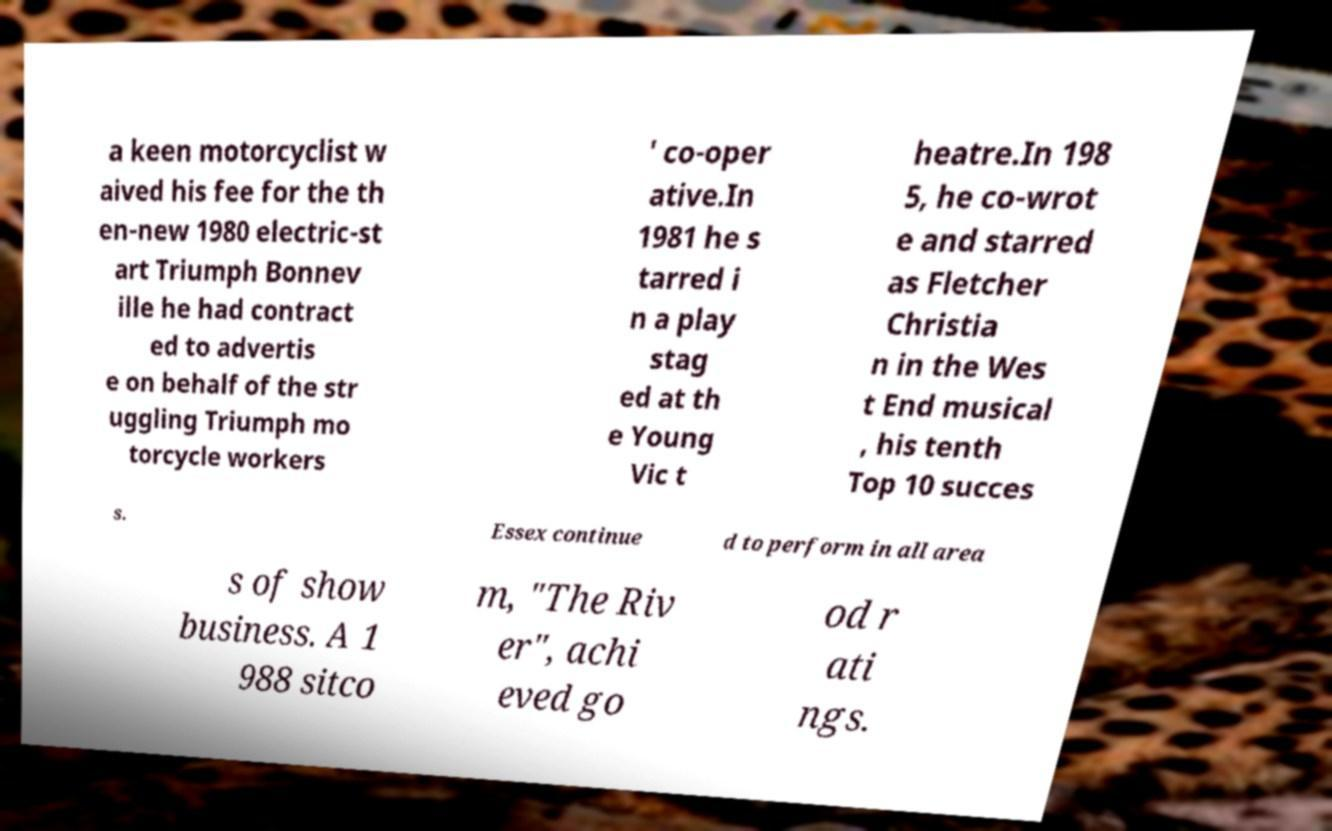Please read and relay the text visible in this image. What does it say? a keen motorcyclist w aived his fee for the th en-new 1980 electric-st art Triumph Bonnev ille he had contract ed to advertis e on behalf of the str uggling Triumph mo torcycle workers ' co-oper ative.In 1981 he s tarred i n a play stag ed at th e Young Vic t heatre.In 198 5, he co-wrot e and starred as Fletcher Christia n in the Wes t End musical , his tenth Top 10 succes s. Essex continue d to perform in all area s of show business. A 1 988 sitco m, "The Riv er", achi eved go od r ati ngs. 